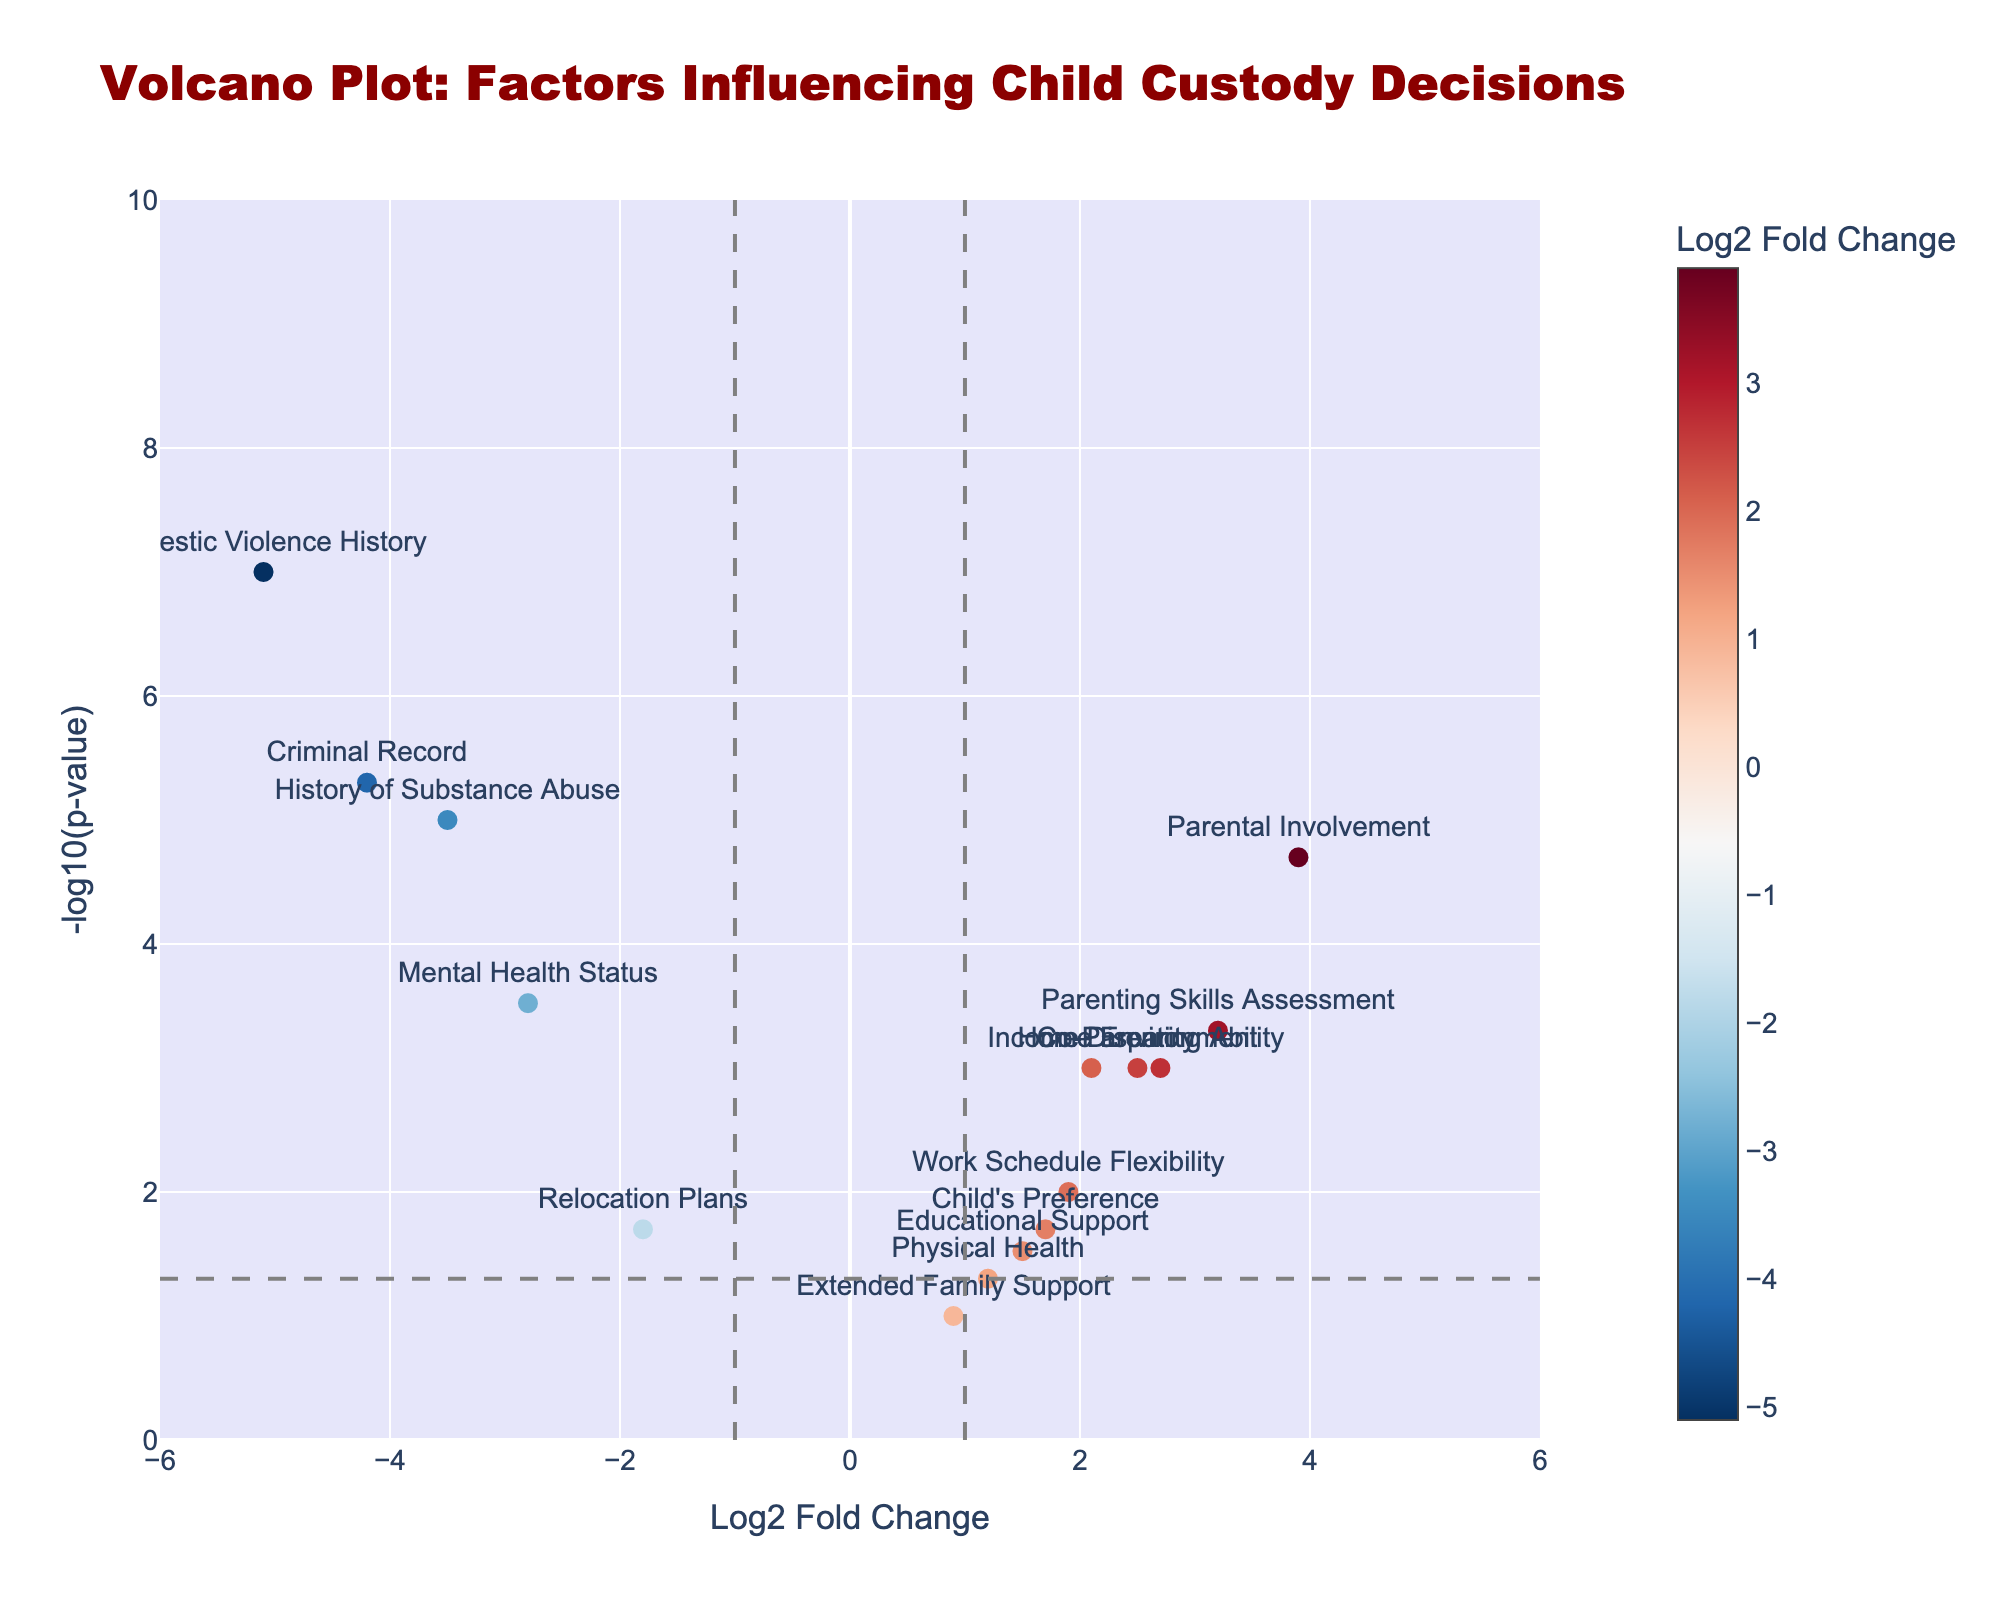How many data points are plotted on the volcano plot? To determine the number of data points, count the number of different factors mentioned on the plot. Here, each factor represents one data point. There are 15 factors listed in the provided data.
Answer: 15 What are the titles of the axes and what do they represent? The x-axis is titled "Log2 Fold Change" which represents how much a factor changes (in log base 2) when comparing two conditions or groups. The y-axis is titled "-log10(p-value)" which represents the statistical significance of the changes for each factor, with higher values indicating more statistically significant results.
Answer: Log2 Fold Change, -log10(p-value) Which factor has the highest magnitude of -log10(p-value)? To find the factor with the highest magnitude of -log10(p-value), look for the point that is the highest on the y-axis. "Domestic Violence History" has the highest value here.
Answer: Domestic Violence History Which factor has the greatest positive Log2 Fold Change? To find the factor with the greatest positive Log2 Fold Change, look for the point that is the farthest to the right on the x-axis. "Parental Involvement" is the farthest to the right.
Answer: Parental Involvement Which factors fall below the p-value threshold of 0.05? The p-value threshold of 0.05 corresponds to a -log10(p-value) of approximately 1.3. All points above this y-axis line have p-values less than 0.05. The factors above this threshold are "Income Disparity," "History of Substance Abuse," "Mental Health Status," "Criminal Record," "Home Environment," "Parental Involvement," "Domestic Violence History," and "Co-Parenting Ability."
Answer: Income Disparity, History of Substance Abuse, Mental Health Status, Criminal Record, Home Environment, Parental Involvement, Domestic Violence History, Co-Parenting Ability What is the fold change range covered by the factors? The maximum Log2 Fold Change is 3.9 (Parental Involvement) and the minimum Log2 Fold Change is -5.1 (Domestic Violence History). The range is 3.9 - (-5.1) = 9.
Answer: 9 Which factors are on the left side of the vertical line at Log2 Fold Change = -1? Factors on the left side of the vertical line with Log2 Fold Change < -1 are "History of Substance Abuse," "Mental Health Status," "Criminal Record," "Relocation Plans," and "Domestic Violence History." These factors have relatively low Log2 Fold Changes.
Answer: History of Substance Abuse, Mental Health Status, Criminal Record, Relocation Plans, Domestic Violence History What is the significance level (-log10(p-value)) of the "Mental Health Status"? To determine this, find the y-value of the point labeled "Mental Health Status." According to the plot data, the value is approximately 3.52.
Answer: 3.52 How does "Child's Preference" compare to "Physical Health" in terms of log2 fold change? Compare the x-values (Log2 Fold Change) of "Child's Preference" (1.7) and "Physical Health" (1.2). "Child's Preference" has a higher Log2 Fold Change than "Physical Health."
Answer: Child's Preference has a higher Log2 Fold Change What is the statistical significance of the "Educational Support" factor? To determine the statistical significance, find its -log10(p-value). For "Educational Support," it is approximately 1.52. Thus, its p-value is 0.03, which is considered statistically significant.
Answer: 1.52 